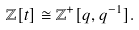<formula> <loc_0><loc_0><loc_500><loc_500>{ \mathbb { Z } } [ t ] \cong \mathbb { Z } ^ { + } [ q , q ^ { - 1 } ] .</formula> 